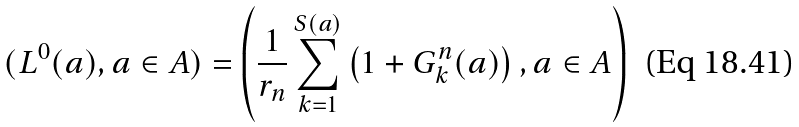<formula> <loc_0><loc_0><loc_500><loc_500>( L ^ { 0 } ( a ) , a \in A ) = \left ( \frac { 1 } { r _ { n } } \sum _ { k = 1 } ^ { S ( a ) } \left ( 1 + G _ { k } ^ { n } ( a ) \right ) , a \in A \right )</formula> 